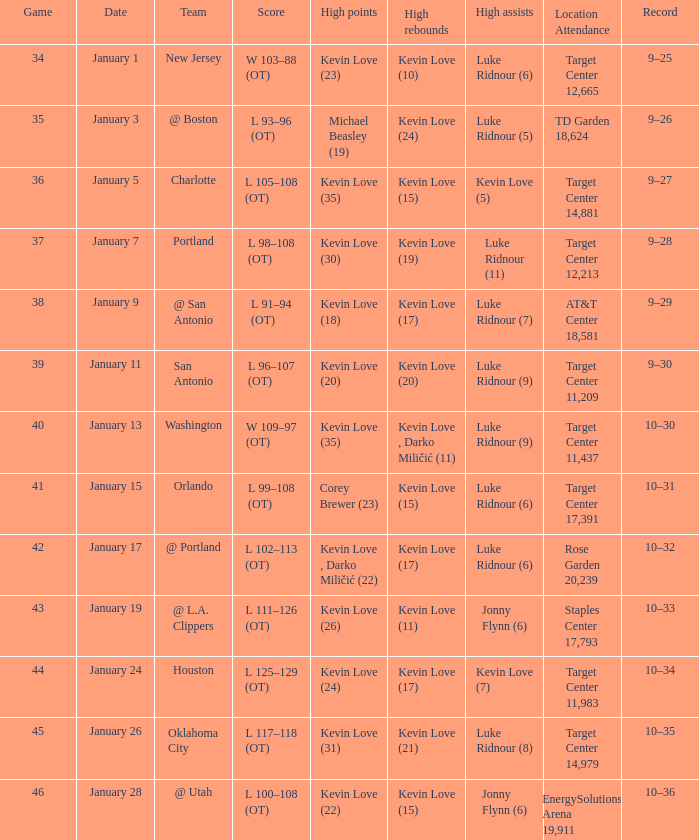Who had the high points when the team was charlotte? Kevin Love (35). 